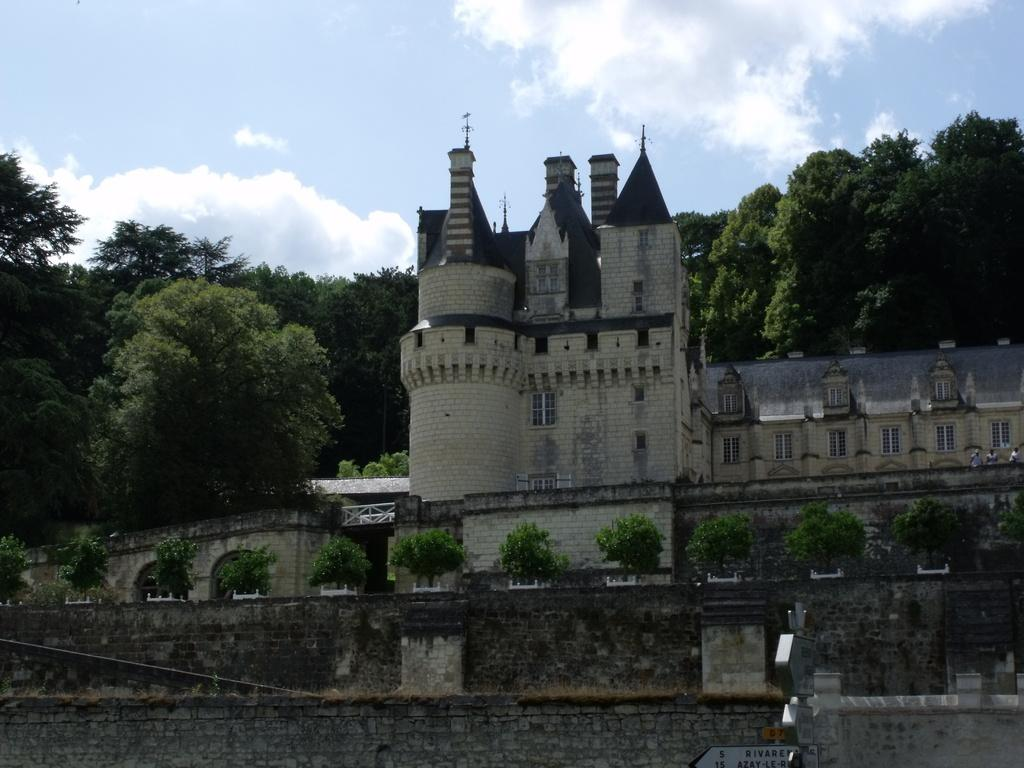What type of structure is present in the image? There is a building in the image. What feature can be seen on the building? The building has windows. What natural elements are visible in the image? There are trees and the sky visible in the image. What is the condition of the sky in the image? The sky has clouds in the image. Who or what can be seen in the image? There are people in the image. What are the people wearing? The people are wearing clothes. What else is present in the image? There is a board in the image. What type of orange is being peeled by the chicken in the image? There is no orange or chicken present in the image. What type of shoes are the people wearing in the image? The provided facts do not mention shoes, so we cannot determine what type of shoes the people are wearing in the image. 